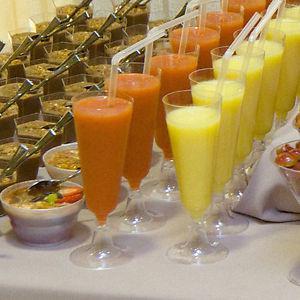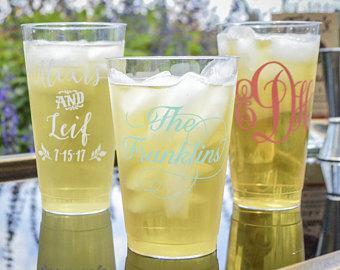The first image is the image on the left, the second image is the image on the right. Considering the images on both sides, is "There are no more than 2 cups in the left image, and they are all plastic." valid? Answer yes or no. No. The first image is the image on the left, the second image is the image on the right. For the images displayed, is the sentence "Some containers are empty." factually correct? Answer yes or no. No. 